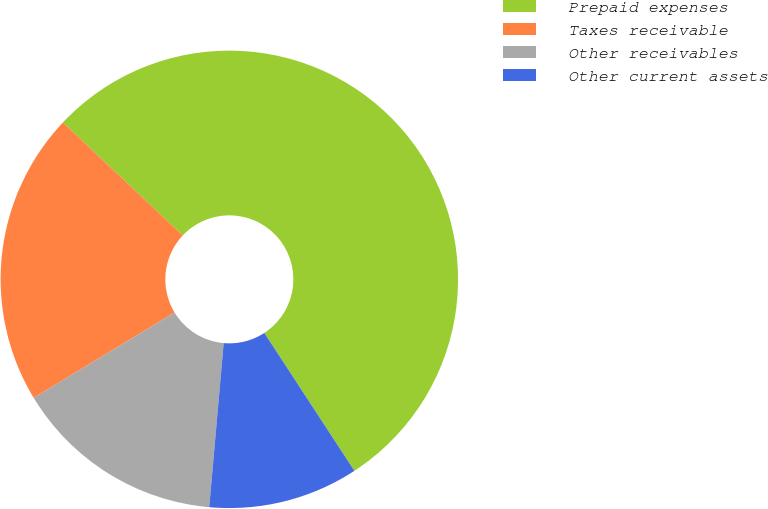<chart> <loc_0><loc_0><loc_500><loc_500><pie_chart><fcel>Prepaid expenses<fcel>Taxes receivable<fcel>Other receivables<fcel>Other current assets<nl><fcel>53.76%<fcel>20.7%<fcel>14.93%<fcel>10.61%<nl></chart> 